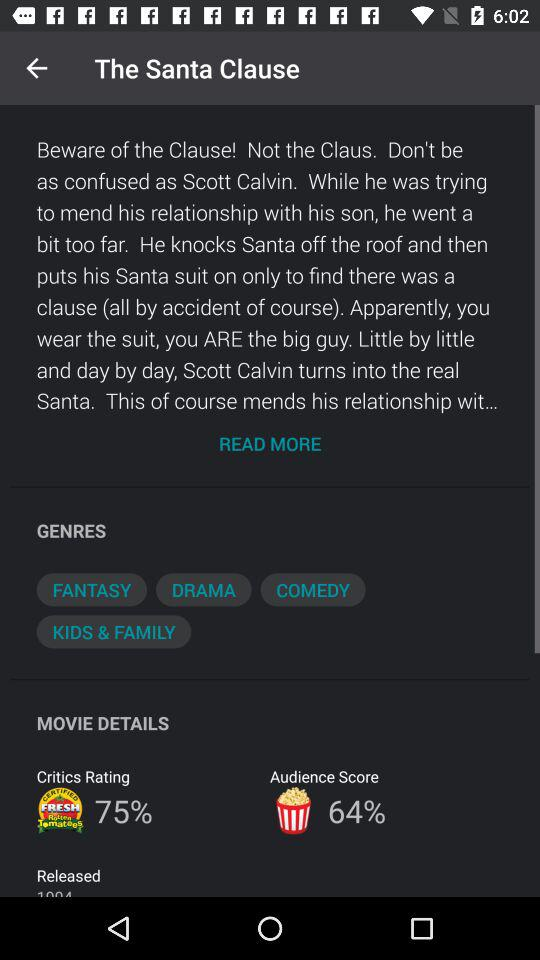What is the difference between the critics rating and the audience score?
Answer the question using a single word or phrase. 11% 